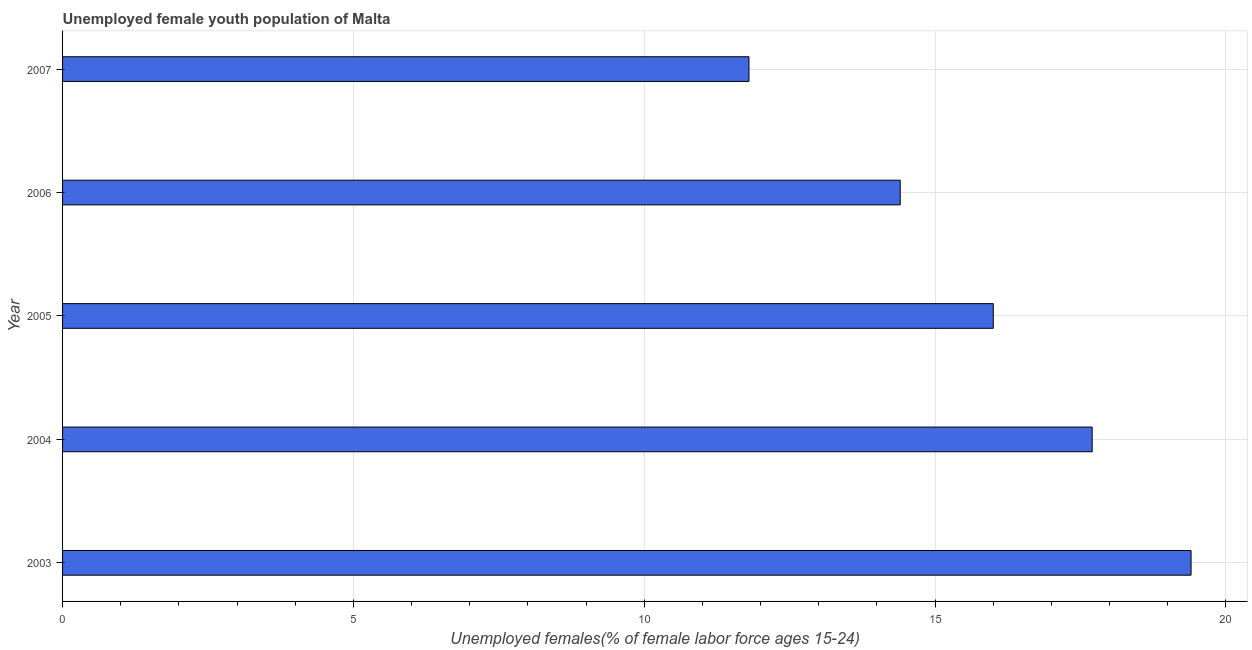Does the graph contain any zero values?
Ensure brevity in your answer.  No. Does the graph contain grids?
Make the answer very short. Yes. What is the title of the graph?
Provide a succinct answer. Unemployed female youth population of Malta. What is the label or title of the X-axis?
Offer a very short reply. Unemployed females(% of female labor force ages 15-24). What is the label or title of the Y-axis?
Provide a succinct answer. Year. What is the unemployed female youth in 2007?
Give a very brief answer. 11.8. Across all years, what is the maximum unemployed female youth?
Offer a very short reply. 19.4. Across all years, what is the minimum unemployed female youth?
Provide a succinct answer. 11.8. What is the sum of the unemployed female youth?
Offer a very short reply. 79.3. What is the average unemployed female youth per year?
Offer a very short reply. 15.86. What is the ratio of the unemployed female youth in 2003 to that in 2006?
Give a very brief answer. 1.35. What is the difference between the highest and the second highest unemployed female youth?
Provide a short and direct response. 1.7. What is the difference between the highest and the lowest unemployed female youth?
Provide a succinct answer. 7.6. What is the difference between two consecutive major ticks on the X-axis?
Make the answer very short. 5. Are the values on the major ticks of X-axis written in scientific E-notation?
Ensure brevity in your answer.  No. What is the Unemployed females(% of female labor force ages 15-24) of 2003?
Provide a short and direct response. 19.4. What is the Unemployed females(% of female labor force ages 15-24) in 2004?
Offer a terse response. 17.7. What is the Unemployed females(% of female labor force ages 15-24) in 2006?
Provide a short and direct response. 14.4. What is the Unemployed females(% of female labor force ages 15-24) of 2007?
Ensure brevity in your answer.  11.8. What is the difference between the Unemployed females(% of female labor force ages 15-24) in 2003 and 2005?
Provide a short and direct response. 3.4. What is the difference between the Unemployed females(% of female labor force ages 15-24) in 2003 and 2006?
Offer a very short reply. 5. What is the difference between the Unemployed females(% of female labor force ages 15-24) in 2003 and 2007?
Provide a succinct answer. 7.6. What is the difference between the Unemployed females(% of female labor force ages 15-24) in 2004 and 2005?
Offer a very short reply. 1.7. What is the difference between the Unemployed females(% of female labor force ages 15-24) in 2005 and 2006?
Ensure brevity in your answer.  1.6. What is the difference between the Unemployed females(% of female labor force ages 15-24) in 2006 and 2007?
Provide a short and direct response. 2.6. What is the ratio of the Unemployed females(% of female labor force ages 15-24) in 2003 to that in 2004?
Your answer should be compact. 1.1. What is the ratio of the Unemployed females(% of female labor force ages 15-24) in 2003 to that in 2005?
Make the answer very short. 1.21. What is the ratio of the Unemployed females(% of female labor force ages 15-24) in 2003 to that in 2006?
Give a very brief answer. 1.35. What is the ratio of the Unemployed females(% of female labor force ages 15-24) in 2003 to that in 2007?
Ensure brevity in your answer.  1.64. What is the ratio of the Unemployed females(% of female labor force ages 15-24) in 2004 to that in 2005?
Make the answer very short. 1.11. What is the ratio of the Unemployed females(% of female labor force ages 15-24) in 2004 to that in 2006?
Offer a very short reply. 1.23. What is the ratio of the Unemployed females(% of female labor force ages 15-24) in 2004 to that in 2007?
Provide a succinct answer. 1.5. What is the ratio of the Unemployed females(% of female labor force ages 15-24) in 2005 to that in 2006?
Your answer should be compact. 1.11. What is the ratio of the Unemployed females(% of female labor force ages 15-24) in 2005 to that in 2007?
Make the answer very short. 1.36. What is the ratio of the Unemployed females(% of female labor force ages 15-24) in 2006 to that in 2007?
Your answer should be very brief. 1.22. 